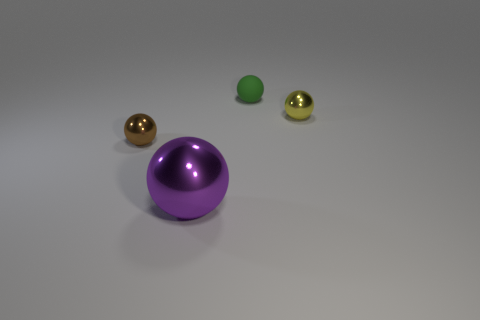Is there any other thing that has the same material as the small green object?
Keep it short and to the point. No. What number of small objects are both to the left of the tiny yellow object and behind the tiny brown metal ball?
Ensure brevity in your answer.  1. How many objects are purple shiny things or metallic things that are behind the brown object?
Provide a succinct answer. 2. There is a small metallic thing in front of the yellow sphere; what is its color?
Your answer should be compact. Brown. What number of things are either small balls right of the tiny brown object or large purple shiny spheres?
Offer a very short reply. 3. There is a matte thing that is the same size as the brown metal ball; what color is it?
Offer a very short reply. Green. Is the number of big things that are on the left side of the green object greater than the number of big yellow rubber cylinders?
Give a very brief answer. Yes. What material is the object that is both in front of the green object and on the right side of the big sphere?
Provide a short and direct response. Metal. Does the tiny metal sphere that is on the left side of the green matte ball have the same color as the metal object that is in front of the brown metallic sphere?
Your answer should be very brief. No. How many other things are there of the same size as the purple object?
Ensure brevity in your answer.  0. 